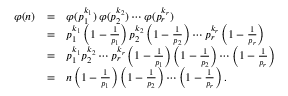<formula> <loc_0><loc_0><loc_500><loc_500>{ \begin{array} { r c l } { \varphi ( n ) } & { = } & { \varphi ( p _ { 1 } ^ { k _ { 1 } } ) \, \varphi ( p _ { 2 } ^ { k _ { 2 } } ) \cdots \varphi ( p _ { r } ^ { k _ { r } } ) } \\ & { = } & { p _ { 1 } ^ { k _ { 1 } } \left ( 1 - { \frac { 1 } { p _ { 1 } } } \right ) p _ { 2 } ^ { k _ { 2 } } \left ( 1 - { \frac { 1 } { p _ { 2 } } } \right ) \cdots p _ { r } ^ { k _ { r } } \left ( 1 - { \frac { 1 } { p _ { r } } } \right ) } \\ & { = } & { p _ { 1 } ^ { k _ { 1 } } p _ { 2 } ^ { k _ { 2 } } \cdots p _ { r } ^ { k _ { r } } \left ( 1 - { \frac { 1 } { p _ { 1 } } } \right ) \left ( 1 - { \frac { 1 } { p _ { 2 } } } \right ) \cdots \left ( 1 - { \frac { 1 } { p _ { r } } } \right ) } \\ & { = } & { n \left ( 1 - { \frac { 1 } { p _ { 1 } } } \right ) \left ( 1 - { \frac { 1 } { p _ { 2 } } } \right ) \cdots \left ( 1 - { \frac { 1 } { p _ { r } } } \right ) . } \end{array} }</formula> 